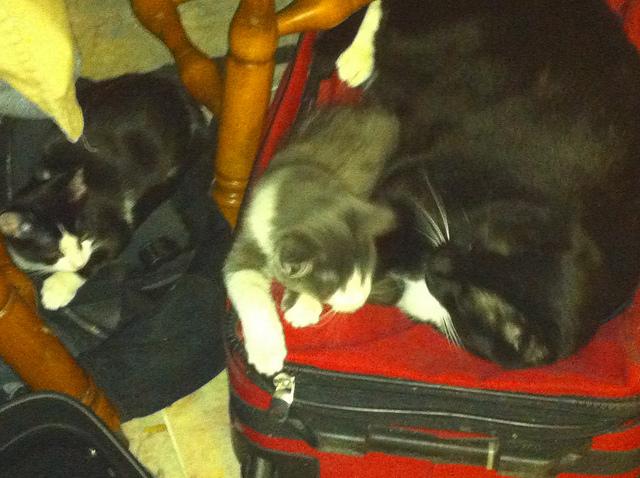How many cats?
Concise answer only. 3. What is the gray kitten sitting on?
Quick response, please. Suitcase. What are the cats doing?
Write a very short answer. Sleeping. 